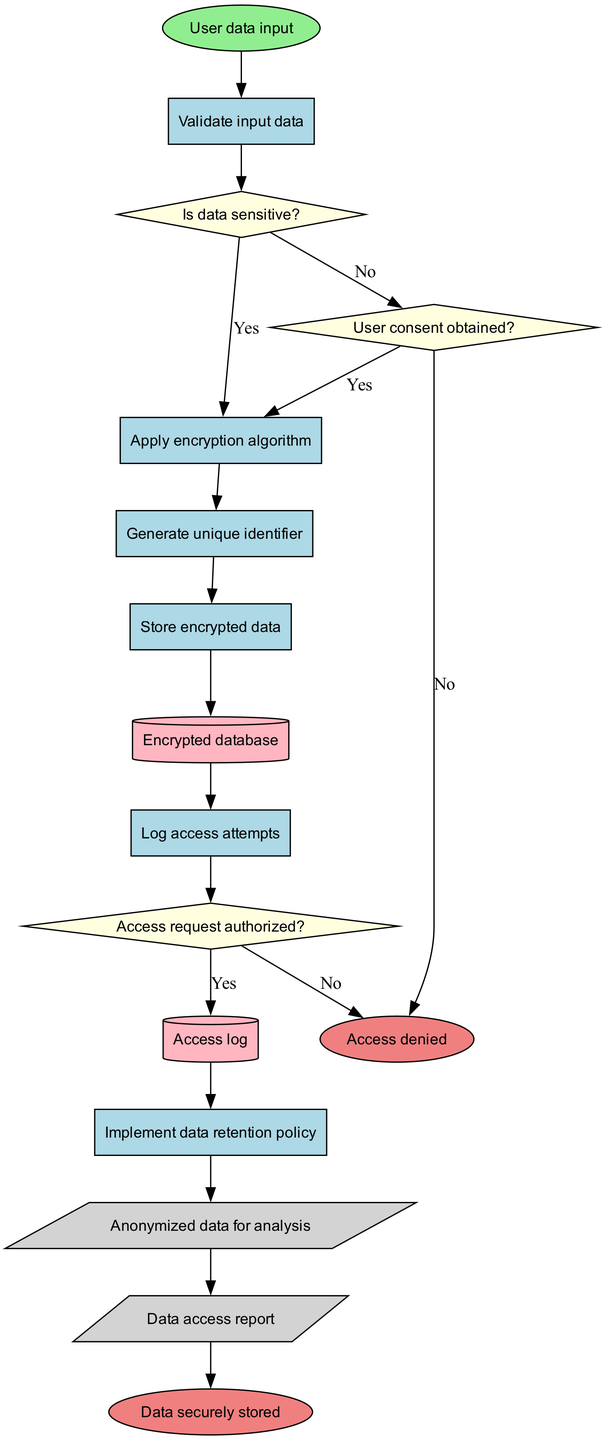What is the first process in the flowchart? The flowchart starts with the "User data input" process, indicating that user data is the initial action in the algorithm.
Answer: User data input How many decision nodes are present in the flowchart? There are three decision nodes in the flowchart, which check conditions such as data sensitivity and user consent.
Answer: 3 What happens to data if user consent is not obtained? If user consent is not obtained, the flowchart directs to the "Access denied" end node, indicating that the data cannot proceed further in the process.
Answer: Access denied What is the output generated after processing the data? After the processing steps and conditions are met, the flowchart outputs two items: "Anonymized data for analysis" and "Data access report."
Answer: Anonymized data for analysis What occurs after logging access attempts? After logging access attempts, the flowchart leads to a decision node where it checks if the access request is authorized, indicating a flow into another decision-making process.
Answer: Decision node How does one proceed from the "Validate input data" process? From the "Validate input data" process, the flowchart proceeds to the decision node that asks, "Is data sensitive?", where the flow diverges based on the response.
Answer: Decision node What type of data store is used to keep the encrypted information? The encrypted information is stored in an "Encrypted database," indicating a specialized data store for securing user data.
Answer: Encrypted database If data is not sensitive, what is the next action taken? If data is not sensitive, the flowchart directs the flow from the first decision to the next process, which involves applying the encryption algorithm.
Answer: Apply encryption algorithm 